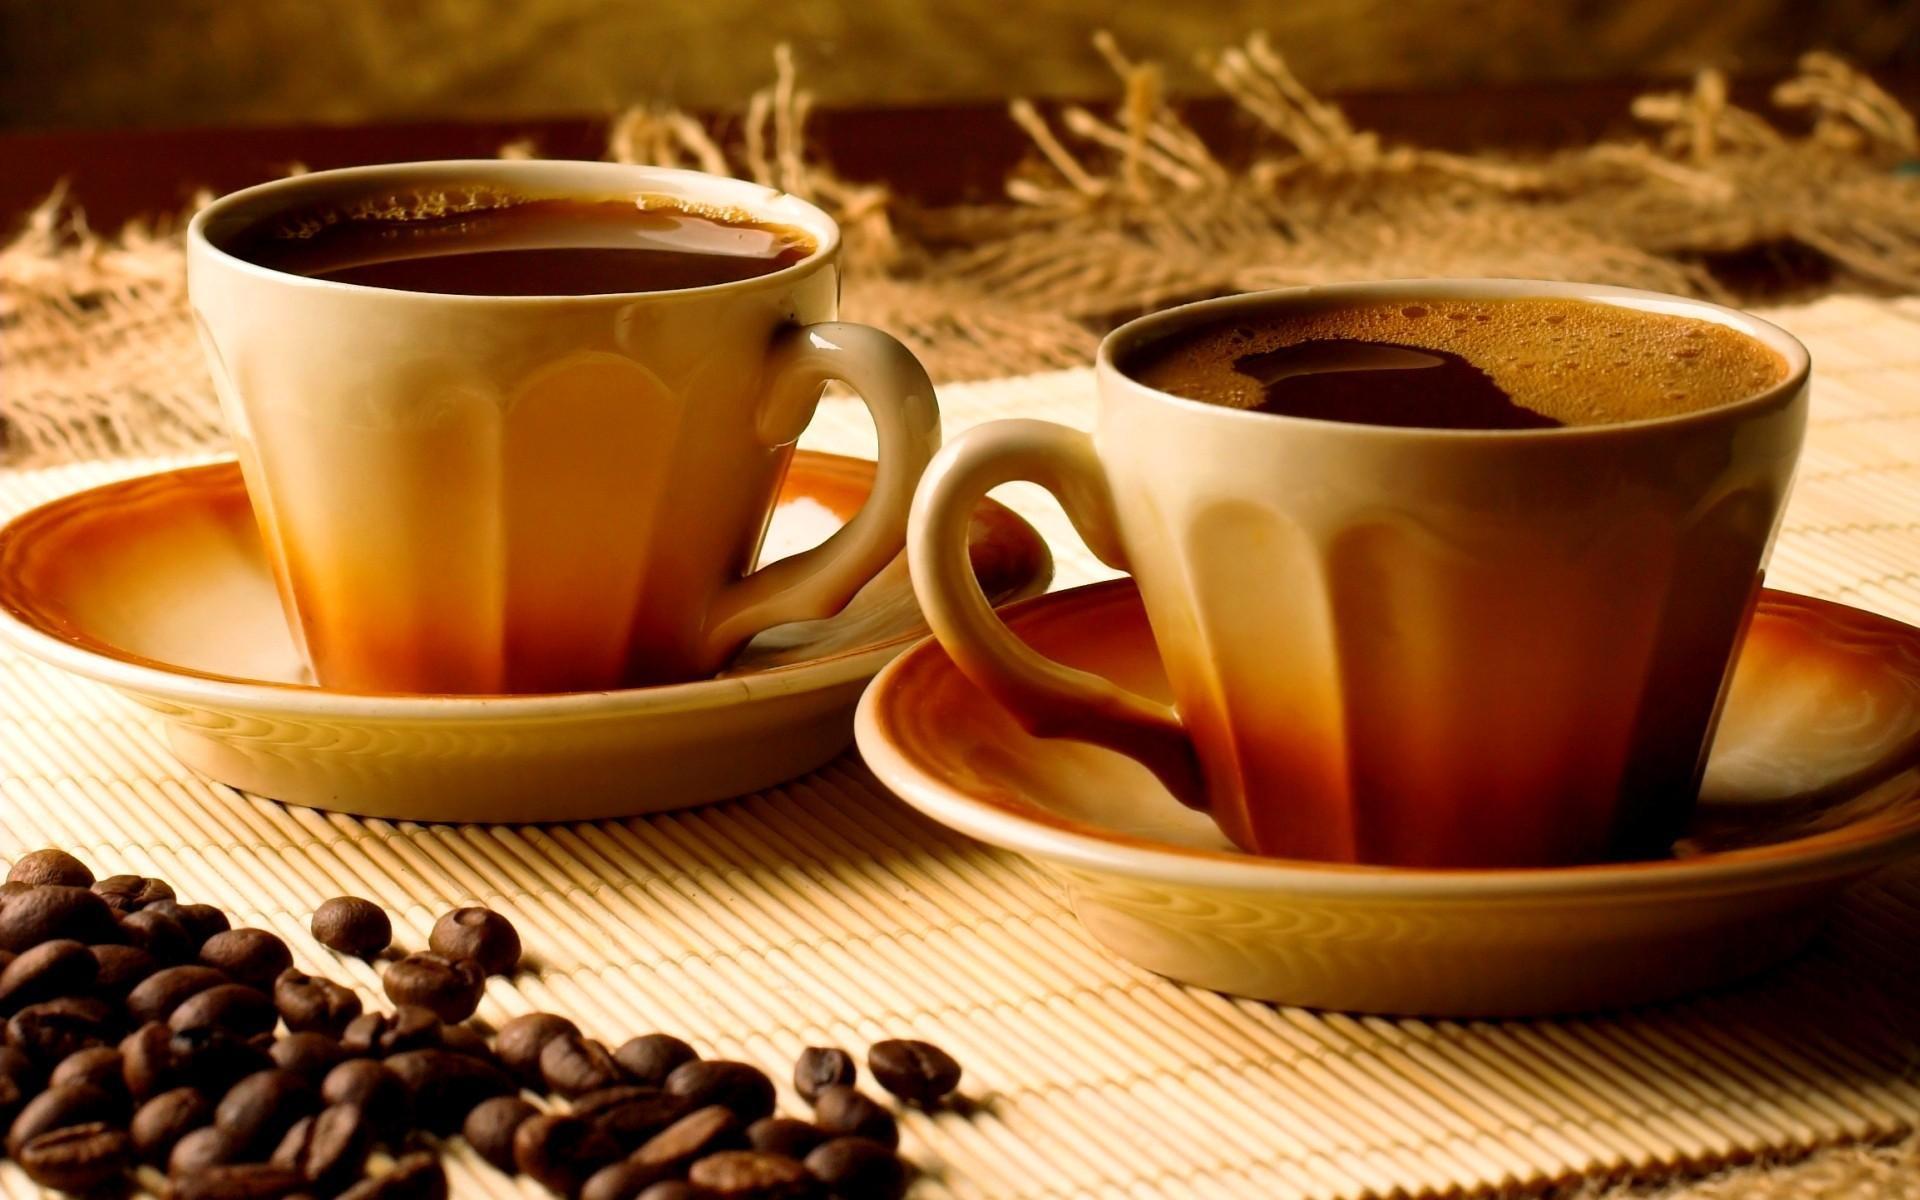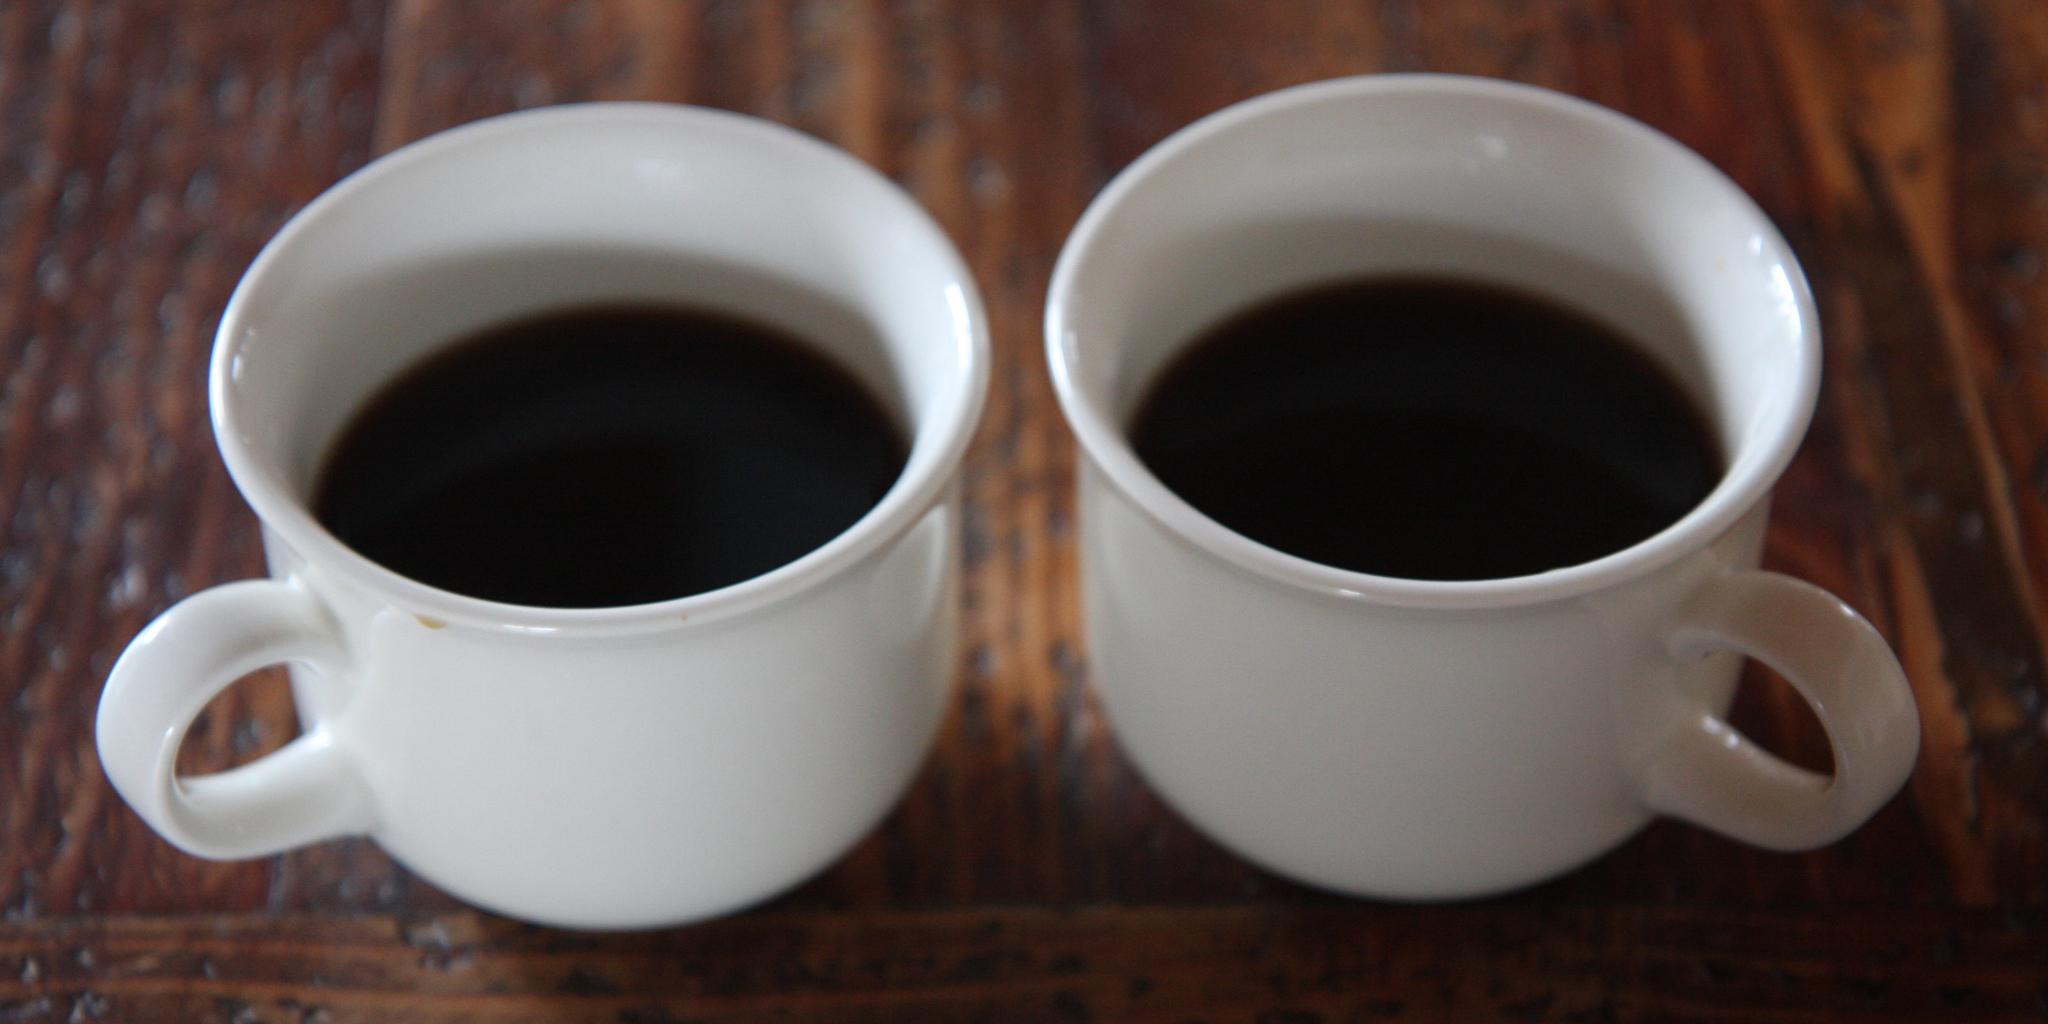The first image is the image on the left, the second image is the image on the right. Evaluate the accuracy of this statement regarding the images: "There are no more than two cups of coffee in the right image.". Is it true? Answer yes or no. Yes. The first image is the image on the left, the second image is the image on the right. Assess this claim about the two images: "there is coffee in sold white cups on a eooden table". Correct or not? Answer yes or no. Yes. 